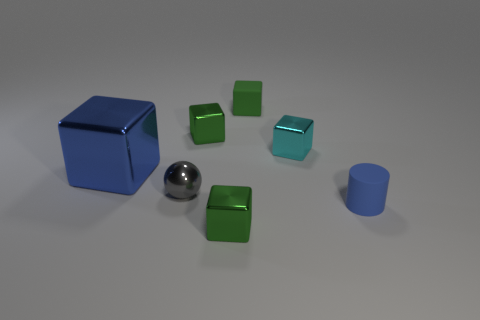Are there fewer large blue metallic blocks behind the small green matte thing than large things?
Provide a succinct answer. Yes. How many small green matte things are there?
Give a very brief answer. 1. What number of blue objects are made of the same material as the tiny gray sphere?
Your answer should be compact. 1. How many things are green metal things behind the small cyan cube or metal cubes?
Make the answer very short. 4. Are there fewer tiny green rubber things that are to the left of the tiny matte block than small metallic cubes that are in front of the small rubber cylinder?
Keep it short and to the point. Yes. There is a gray metallic sphere; are there any tiny blue objects left of it?
Your answer should be compact. No. How many objects are either green objects left of the rubber cube or small objects that are right of the gray object?
Keep it short and to the point. 5. How many matte things have the same color as the big metallic thing?
Keep it short and to the point. 1. What is the color of the rubber thing that is the same shape as the big blue metallic thing?
Ensure brevity in your answer.  Green. The tiny object that is on the left side of the small cyan block and in front of the small gray object has what shape?
Keep it short and to the point. Cube. 